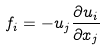<formula> <loc_0><loc_0><loc_500><loc_500>f _ { i } = - u _ { j } \frac { \partial u _ { i } } { \partial x _ { j } }</formula> 